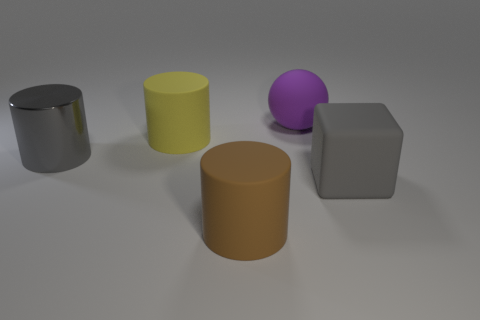Subtract all yellow rubber cylinders. How many cylinders are left? 2 Subtract 1 cylinders. How many cylinders are left? 2 Add 1 big brown matte cylinders. How many objects exist? 6 Subtract all cylinders. How many objects are left? 2 Add 4 large gray metal cylinders. How many large gray metal cylinders are left? 5 Add 1 gray rubber cylinders. How many gray rubber cylinders exist? 1 Subtract 0 cyan balls. How many objects are left? 5 Subtract all gray cylinders. Subtract all red balls. How many cylinders are left? 2 Subtract all small blue cylinders. Subtract all rubber cylinders. How many objects are left? 3 